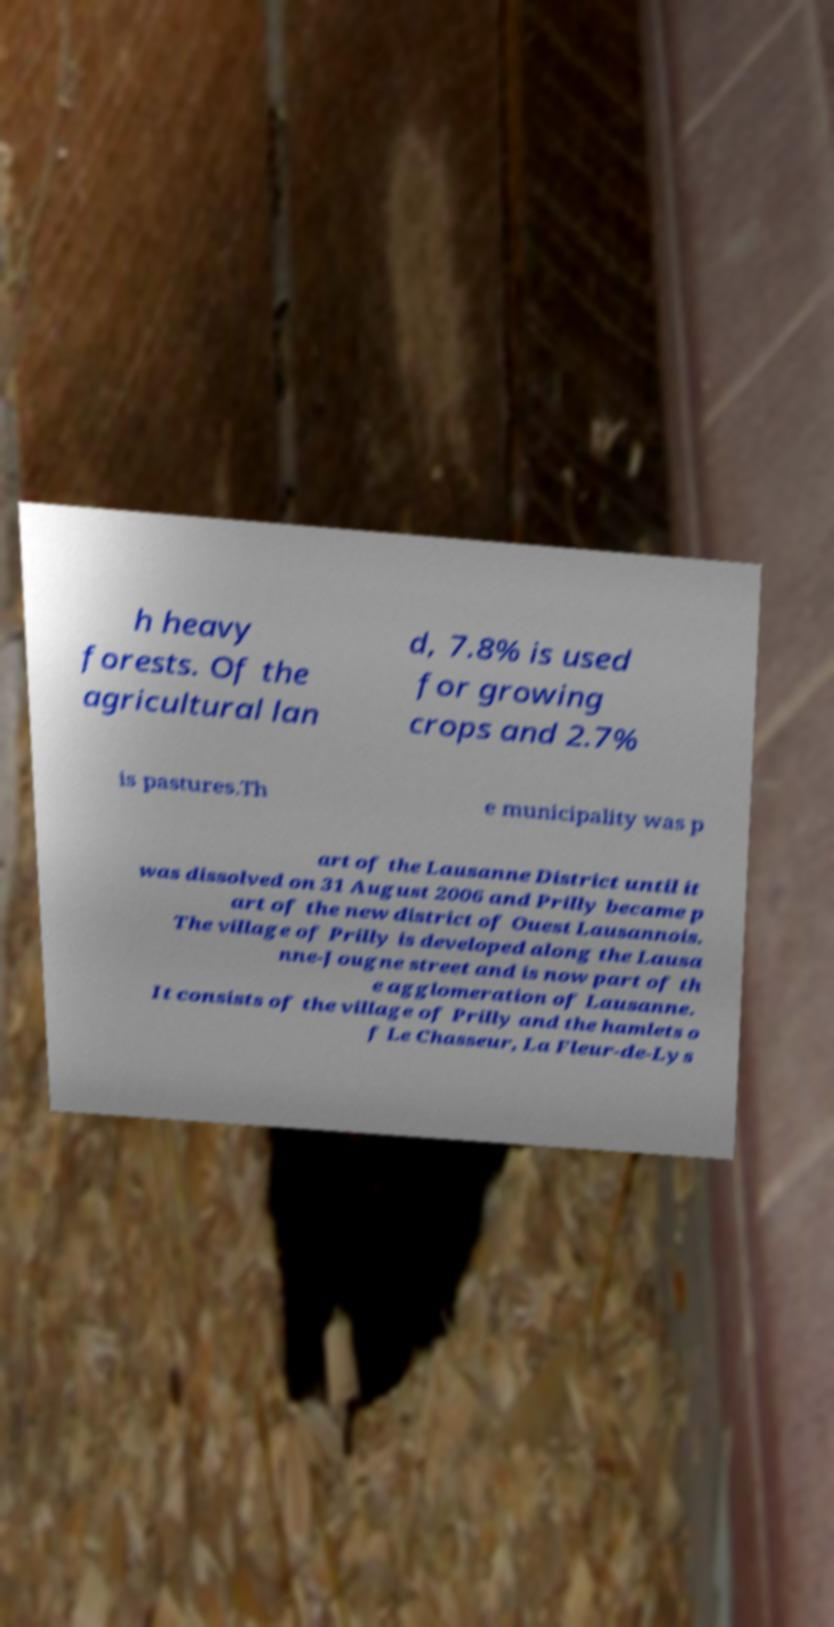For documentation purposes, I need the text within this image transcribed. Could you provide that? h heavy forests. Of the agricultural lan d, 7.8% is used for growing crops and 2.7% is pastures.Th e municipality was p art of the Lausanne District until it was dissolved on 31 August 2006 and Prilly became p art of the new district of Ouest Lausannois. The village of Prilly is developed along the Lausa nne-Jougne street and is now part of th e agglomeration of Lausanne. It consists of the village of Prilly and the hamlets o f Le Chasseur, La Fleur-de-Lys 